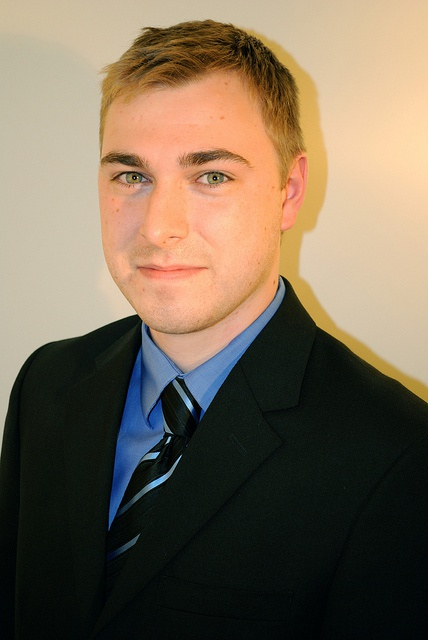Describe the objects in this image and their specific colors. I can see people in black, tan, and olive tones and tie in tan, black, gray, blue, and lightblue tones in this image. 